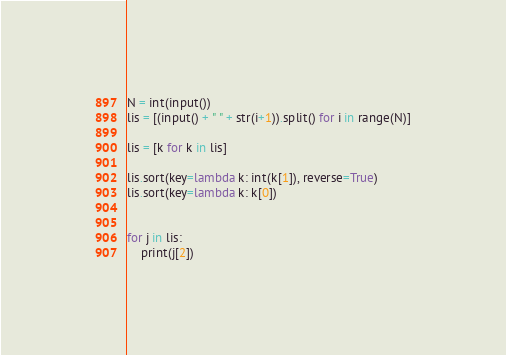<code> <loc_0><loc_0><loc_500><loc_500><_Python_>N = int(input())
lis = [(input() + " " + str(i+1)).split() for i in range(N)]

lis = [k for k in lis]

lis.sort(key=lambda k: int(k[1]), reverse=True)
lis.sort(key=lambda k: k[0])


for j in lis:
    print(j[2])
</code> 